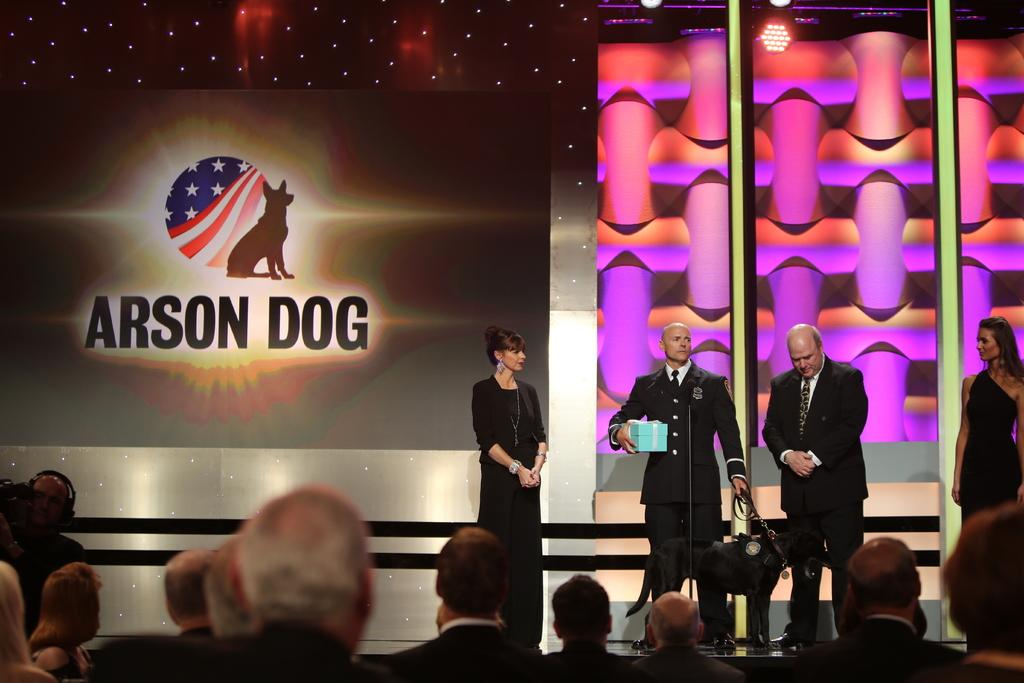Provide a one-sentence caption for the provided image. Four people are on stage in front of a wall that says Arson Dog. 